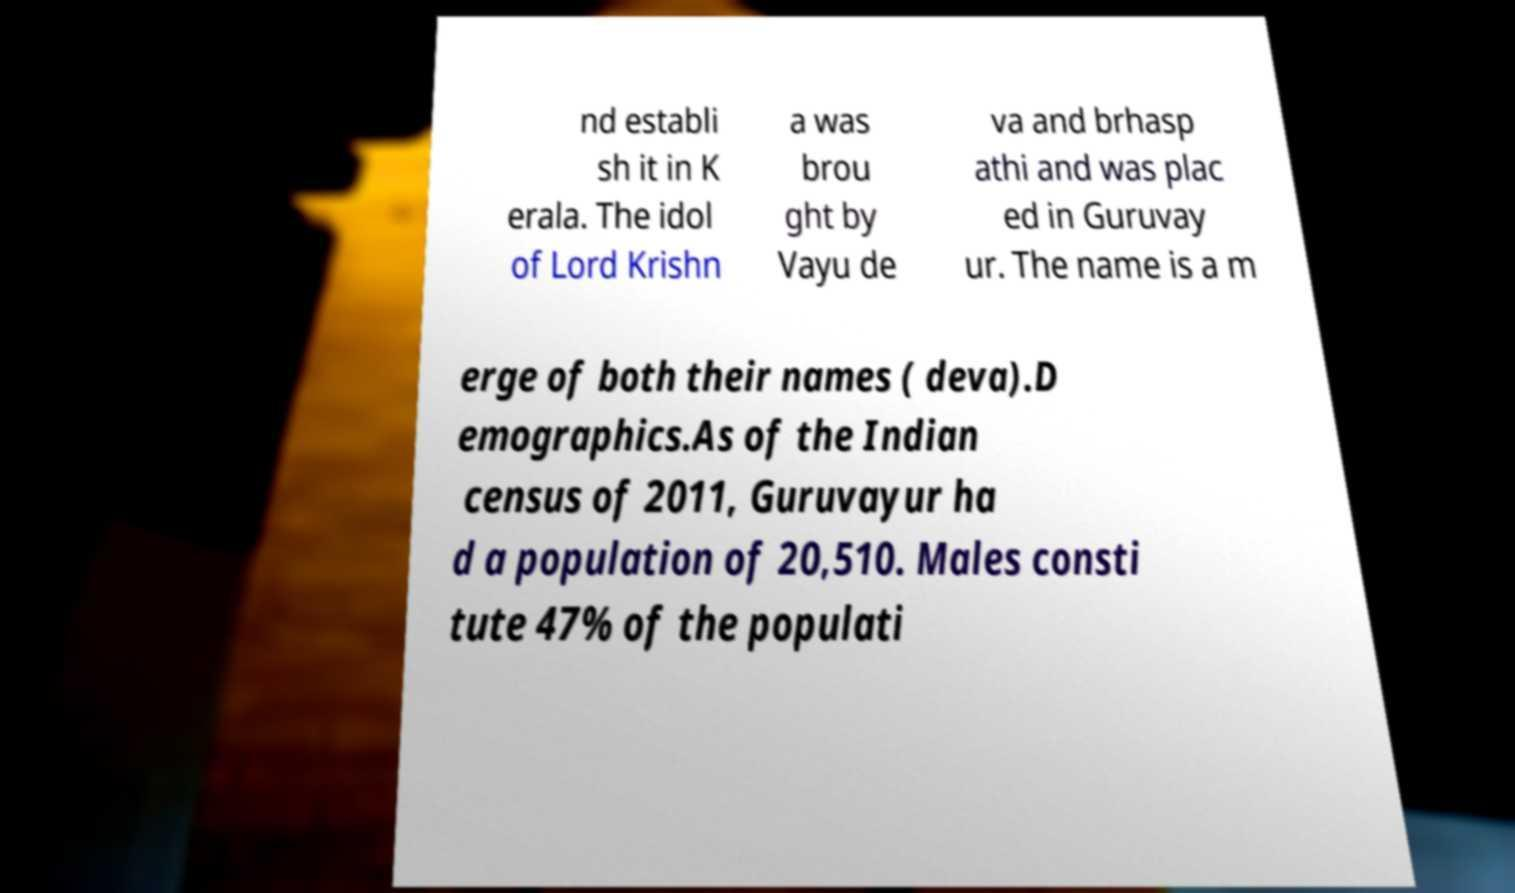There's text embedded in this image that I need extracted. Can you transcribe it verbatim? nd establi sh it in K erala. The idol of Lord Krishn a was brou ght by Vayu de va and brhasp athi and was plac ed in Guruvay ur. The name is a m erge of both their names ( deva).D emographics.As of the Indian census of 2011, Guruvayur ha d a population of 20,510. Males consti tute 47% of the populati 